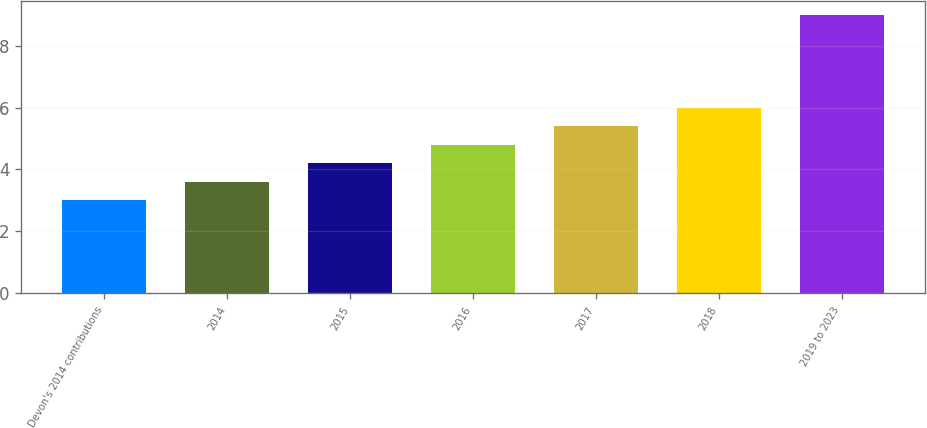<chart> <loc_0><loc_0><loc_500><loc_500><bar_chart><fcel>Devon's 2014 contributions<fcel>2014<fcel>2015<fcel>2016<fcel>2017<fcel>2018<fcel>2019 to 2023<nl><fcel>3<fcel>3.6<fcel>4.2<fcel>4.8<fcel>5.4<fcel>6<fcel>9<nl></chart> 